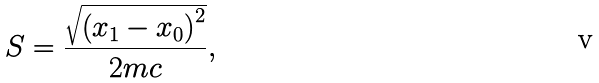<formula> <loc_0><loc_0><loc_500><loc_500>S = \frac { \sqrt { \left ( x _ { 1 } - x _ { 0 } \right ) ^ { 2 } } } { 2 m c } ,</formula> 